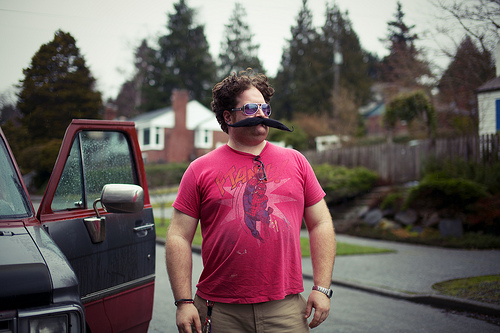<image>
Can you confirm if the man is next to the door? Yes. The man is positioned adjacent to the door, located nearby in the same general area. Where is the tree in relation to the car? Is it above the car? No. The tree is not positioned above the car. The vertical arrangement shows a different relationship. 